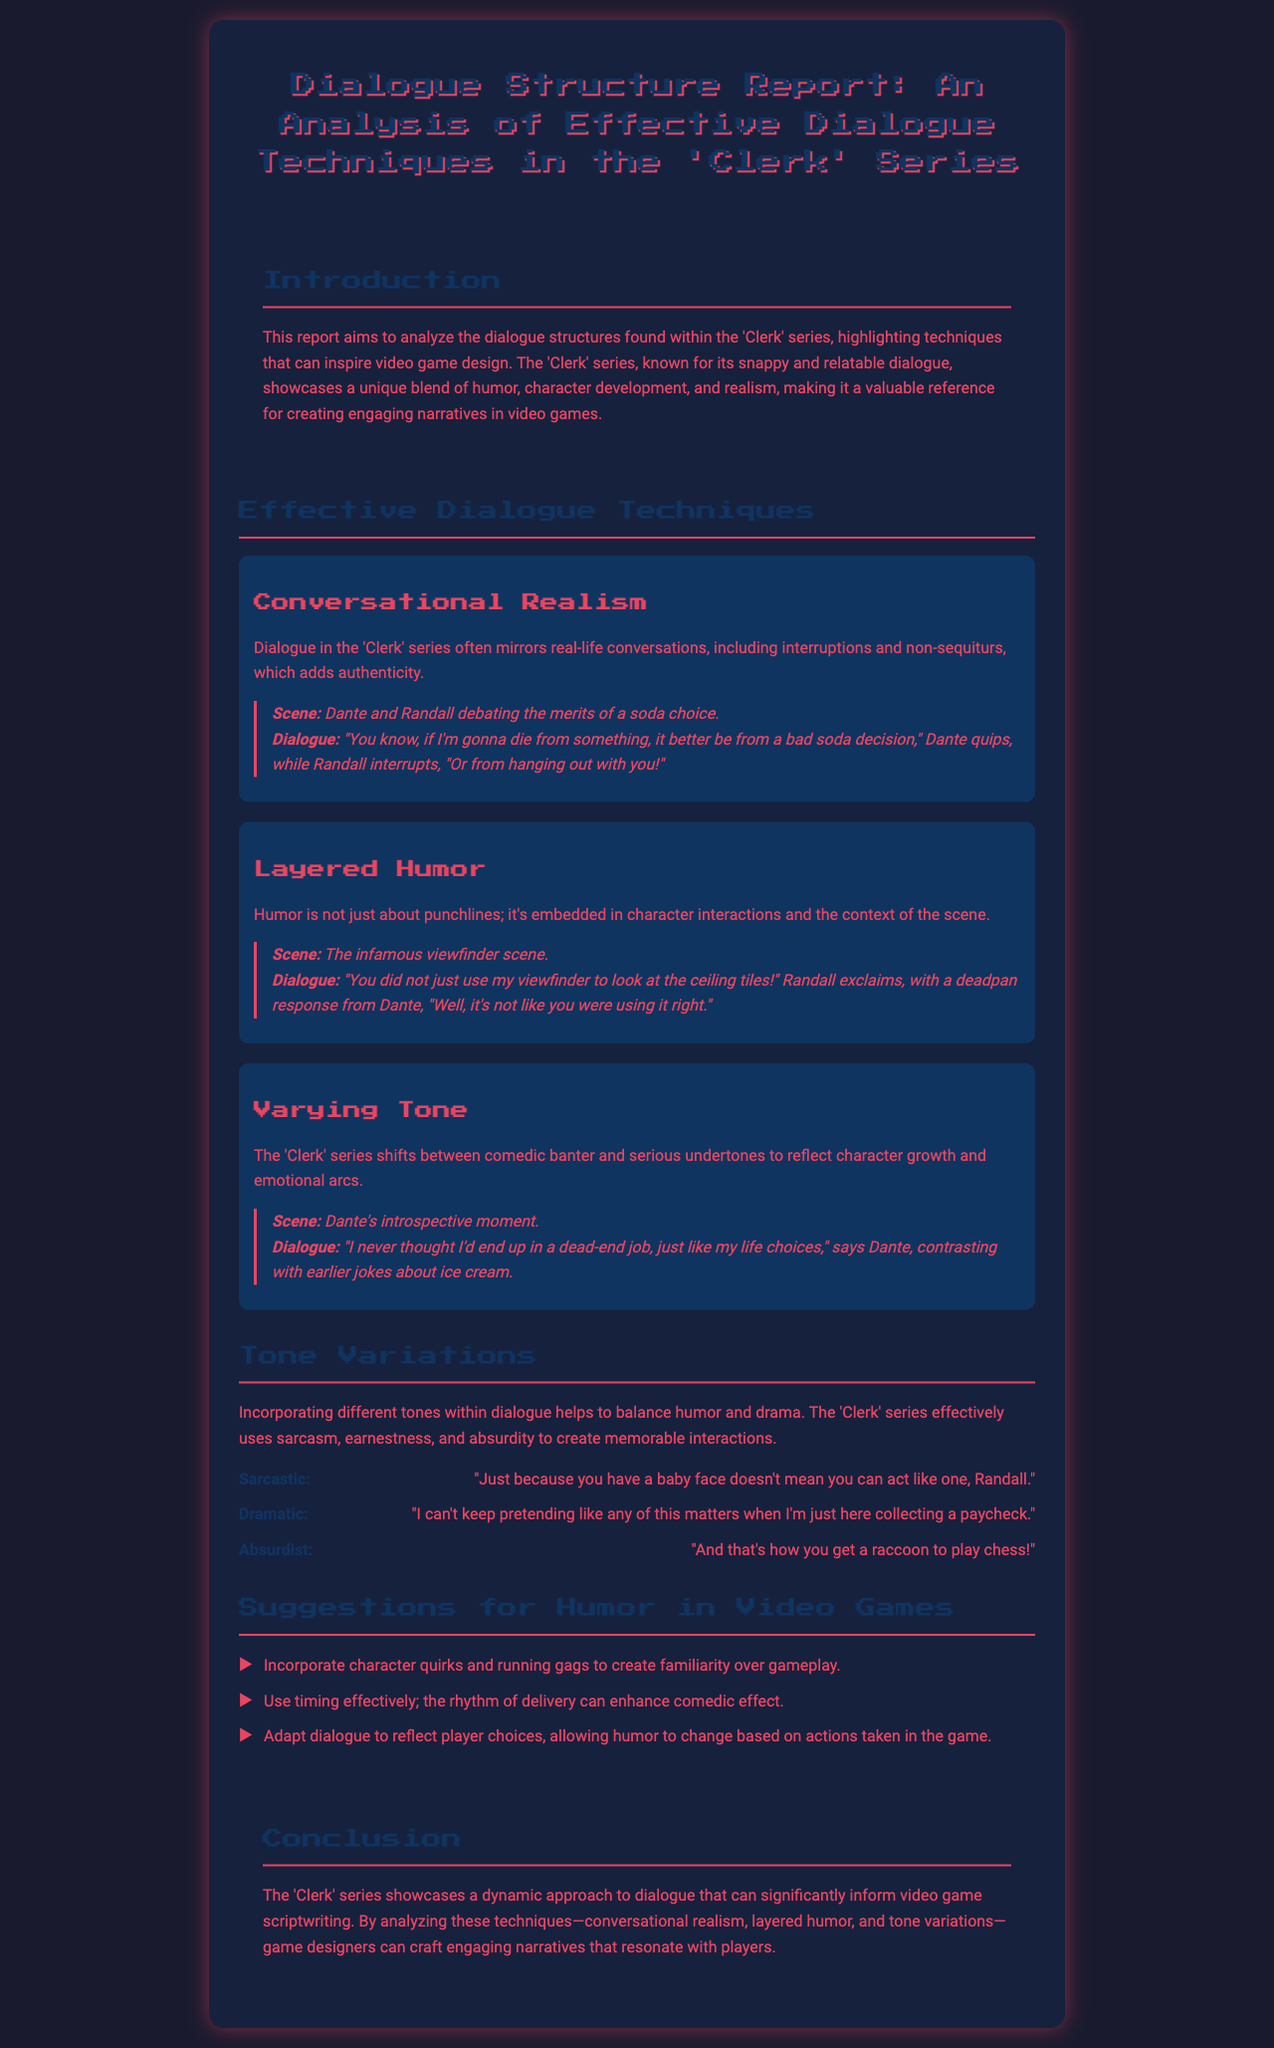What is the title of the report? The title of the report is found at the beginning of the document.
Answer: Dialogue Structure Report: An Analysis of Effective Dialogue Techniques in the 'Clerk' Series Who wrote the report? The report does not explicitly mention the author's name, but it presents an analysis of the 'Clerk' series.
Answer: Not mentioned What is the main focus of the report? The main focus is to analyze dialogue structures seen in the 'Clerk' series.
Answer: Dialogue structures How many effective dialogue techniques are discussed? The report lists three effective dialogue techniques under the section titled "Effective Dialogue Techniques."
Answer: Three Which technique involves real-life conversation mimicking? The dialogue technique that involves this characteristic is identified in the report.
Answer: Conversational Realism What scene is described in the context of layered humor? The report provides an example scene illustrating this technique.
Answer: The infamous viewfinder scene What tone is associated with the phrase, "I can't keep pretending like any of this matters"? This phrase represents a serious emotional expression in the document's examples.
Answer: Dramatic Name one suggestion for incorporating humor in video games. A suggestion presented in the report addresses an aspect of character interactions and humor.
Answer: Incorporate character quirks What is the overall conclusion about the 'Clerk' series dialogue? The conclusion provides insights on the impact of the dialogue on video game scriptwriting.
Answer: Dynamic approach to dialogue 